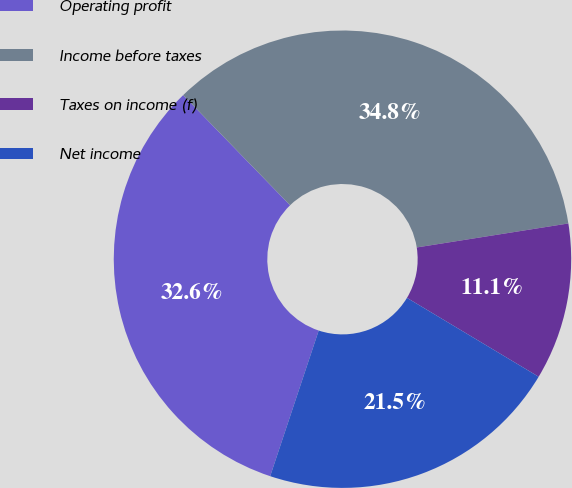Convert chart to OTSL. <chart><loc_0><loc_0><loc_500><loc_500><pie_chart><fcel>Operating profit<fcel>Income before taxes<fcel>Taxes on income (f)<fcel>Net income<nl><fcel>32.62%<fcel>34.77%<fcel>11.09%<fcel>21.53%<nl></chart> 